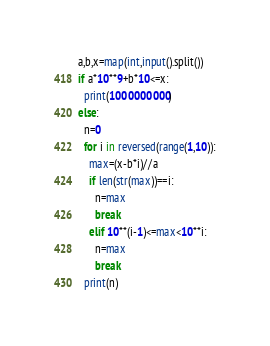Convert code to text. <code><loc_0><loc_0><loc_500><loc_500><_Python_>a,b,x=map(int,input().split())
if a*10**9+b*10<=x:
  print(1000000000)
else:
  n=0
  for i in reversed(range(1,10)):
    max=(x-b*i)//a
    if len(str(max))==i:
      n=max
      break
    elif 10**(i-1)<=max<10**i:
      n=max
      break
  print(n)</code> 